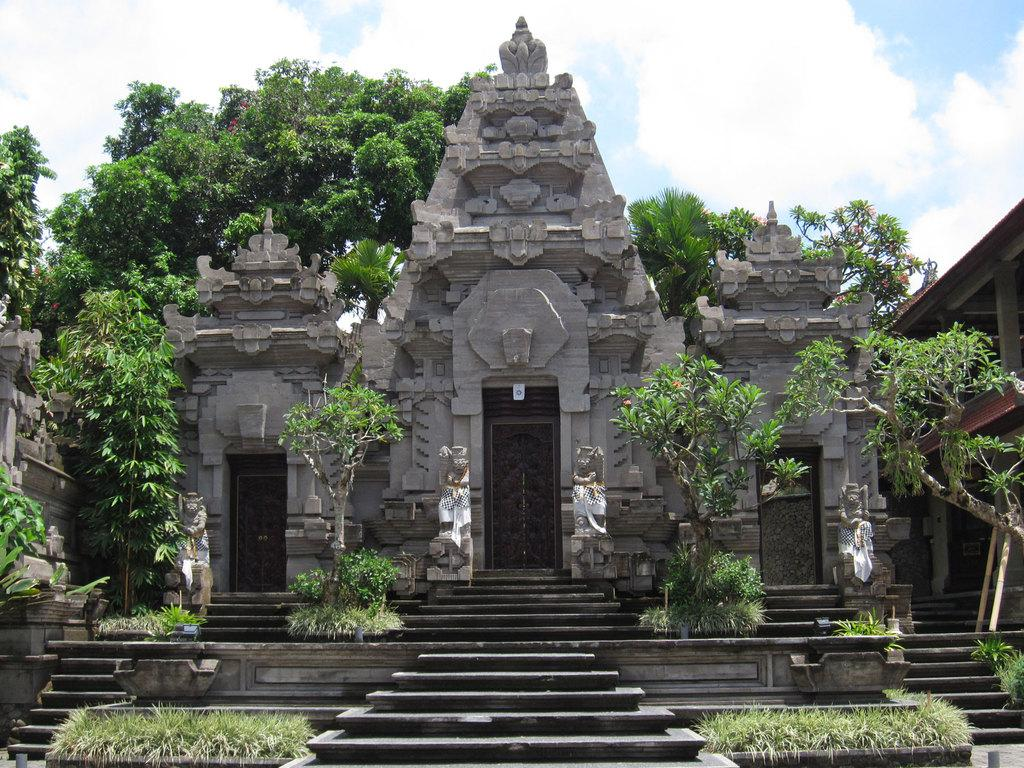What type of building is in the image? There is a stone building in the image. What can be used to enter or exit the building? There are doors in the image. How can one access different levels of the building? There are stairs in the image. What type of vegetation is visible in the image? There is: There is grass, plants, and trees visible in the image. What is the condition of the sky in the image? The sky is cloudy in the image. What type of chin can be seen on the building in the image? There is no chin present on the building in the image; it is a stone structure without any facial features. 